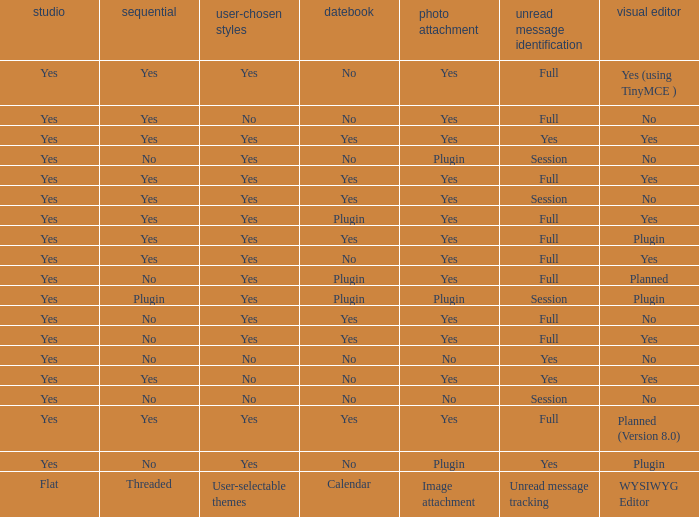Which WYSIWYG Editor has an Image attachment of yes, and a Calendar of plugin? Yes, Planned. 